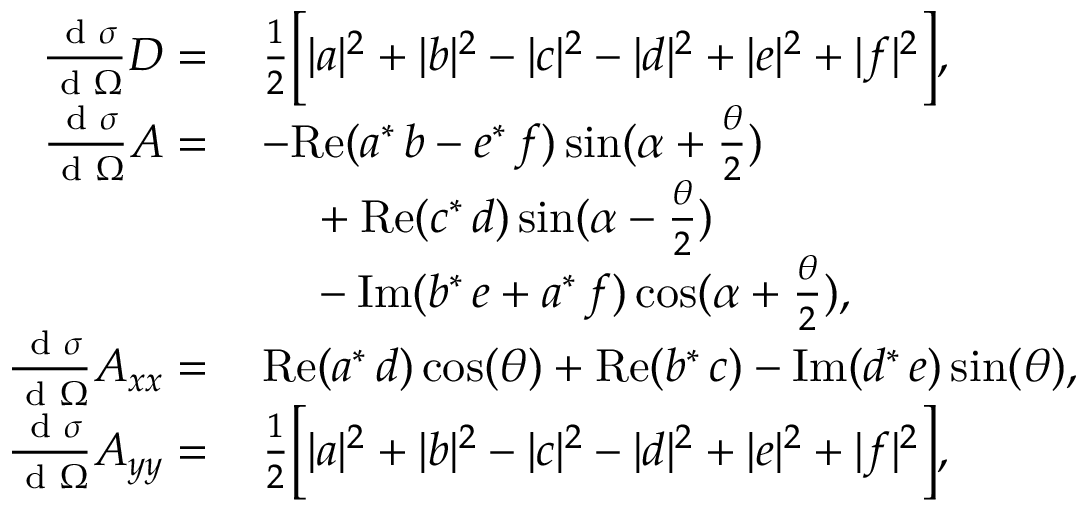Convert formula to latex. <formula><loc_0><loc_0><loc_500><loc_500>\begin{array} { r l } { \frac { d \sigma } { d \Omega } D = \, } & { \frac { 1 } { 2 } \left [ | a | ^ { 2 } + | b | ^ { 2 } - | c | ^ { 2 } - | d | ^ { 2 } + | e | ^ { 2 } + | f | ^ { 2 } \right ] , } \\ { \frac { d \sigma } { d \Omega } A = \, } & { - R e ( a ^ { * } \, b - e ^ { * } \, f ) \sin ( \alpha + \frac { \theta } { 2 } ) } \\ & { \quad \null + R e ( c ^ { * } \, d ) \sin ( \alpha - \frac { \theta } { 2 } ) } \\ & { \quad \null - I m ( b ^ { * } \, e + a ^ { * } \, f ) \cos ( \alpha + \frac { \theta } { 2 } ) , } \\ { \frac { d \sigma } { d \Omega } A _ { x x } = \, } & { R e ( a ^ { * } \, d ) \cos ( \theta ) + R e ( b ^ { * } \, c ) - I m ( d ^ { * } \, e ) \sin ( \theta ) , } \\ { \frac { d \sigma } { d \Omega } A _ { y y } = \, } & { \frac { 1 } { 2 } \left [ | a | ^ { 2 } + | b | ^ { 2 } - | c | ^ { 2 } - | d | ^ { 2 } + | e | ^ { 2 } + | f | ^ { 2 } \right ] , } \end{array}</formula> 